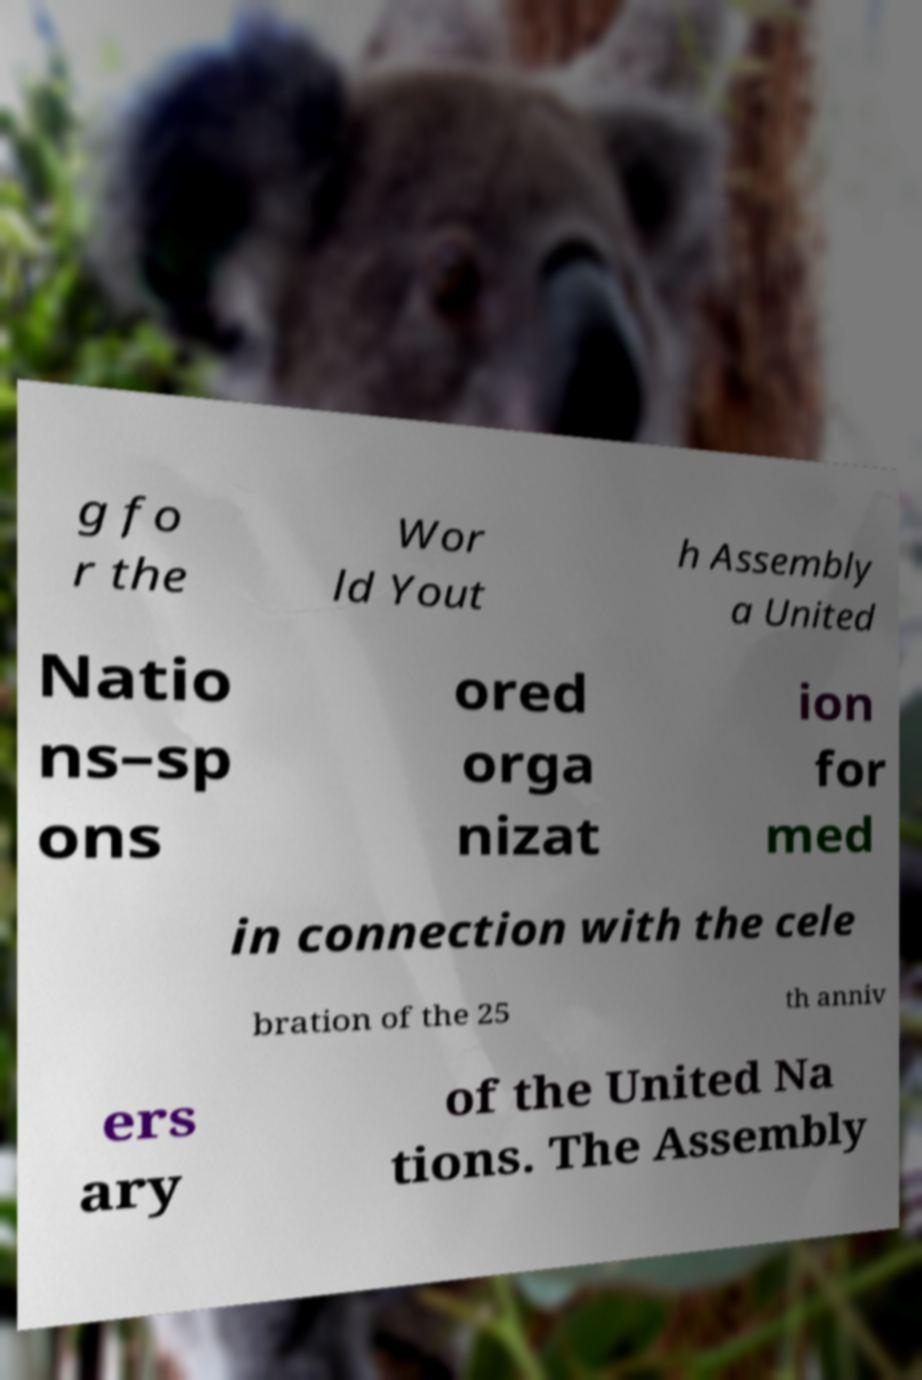Could you assist in decoding the text presented in this image and type it out clearly? g fo r the Wor ld Yout h Assembly a United Natio ns–sp ons ored orga nizat ion for med in connection with the cele bration of the 25 th anniv ers ary of the United Na tions. The Assembly 